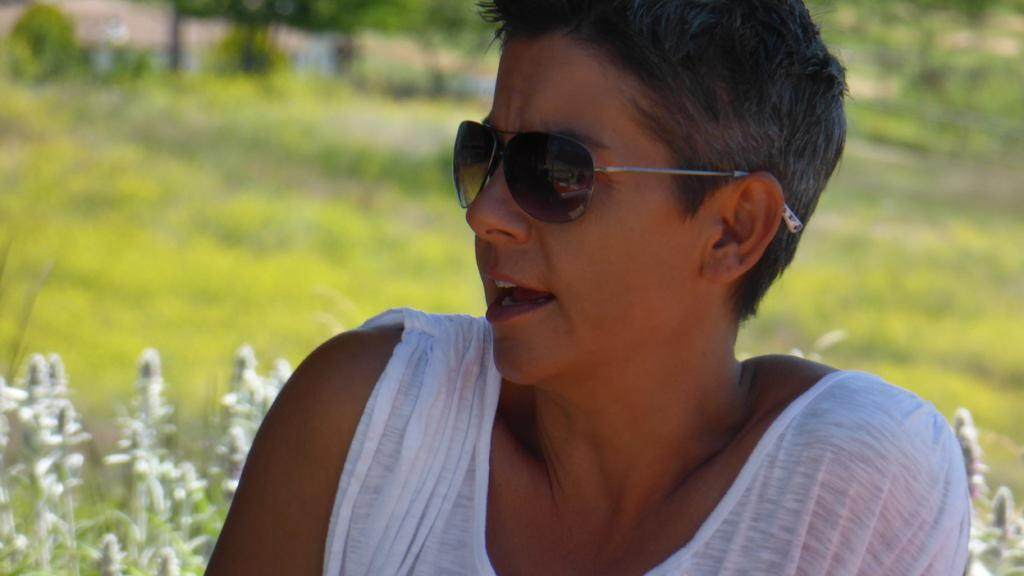What is the main subject in the foreground of the image? There is a person in the foreground of the image. What is the person wearing on their face? The person is wearing goggles. What color is the dress the person is wearing? The person is wearing a white dress. What type of vegetation can be seen at the bottom of the image? There are plants at the bottom of the image. How would you describe the background of the image? The background of the image is blurry. What type of apple is the person holding in the image? There is no apple present in the image; the person is wearing goggles and a white dress. What belief system does the person in the image follow? There is no information about the person's belief system in the image. 